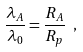<formula> <loc_0><loc_0><loc_500><loc_500>\frac { \lambda _ { A } } { \lambda _ { 0 } } = \frac { R _ { A } } { R _ { p } } \ ,</formula> 